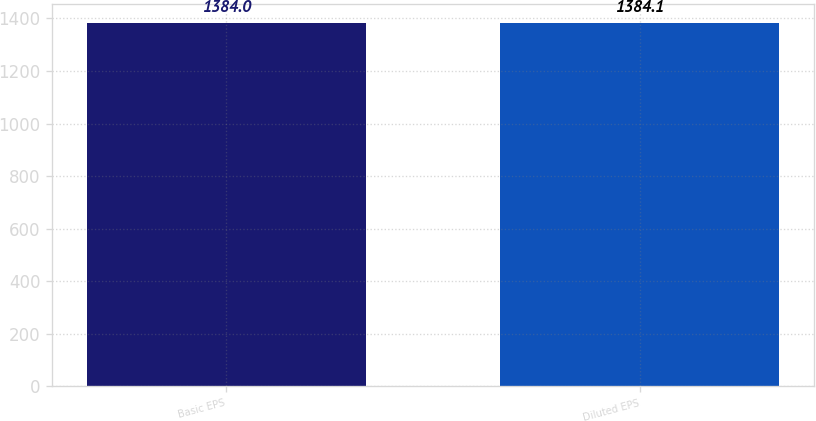<chart> <loc_0><loc_0><loc_500><loc_500><bar_chart><fcel>Basic EPS<fcel>Diluted EPS<nl><fcel>1384<fcel>1384.1<nl></chart> 